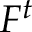Convert formula to latex. <formula><loc_0><loc_0><loc_500><loc_500>F ^ { t }</formula> 